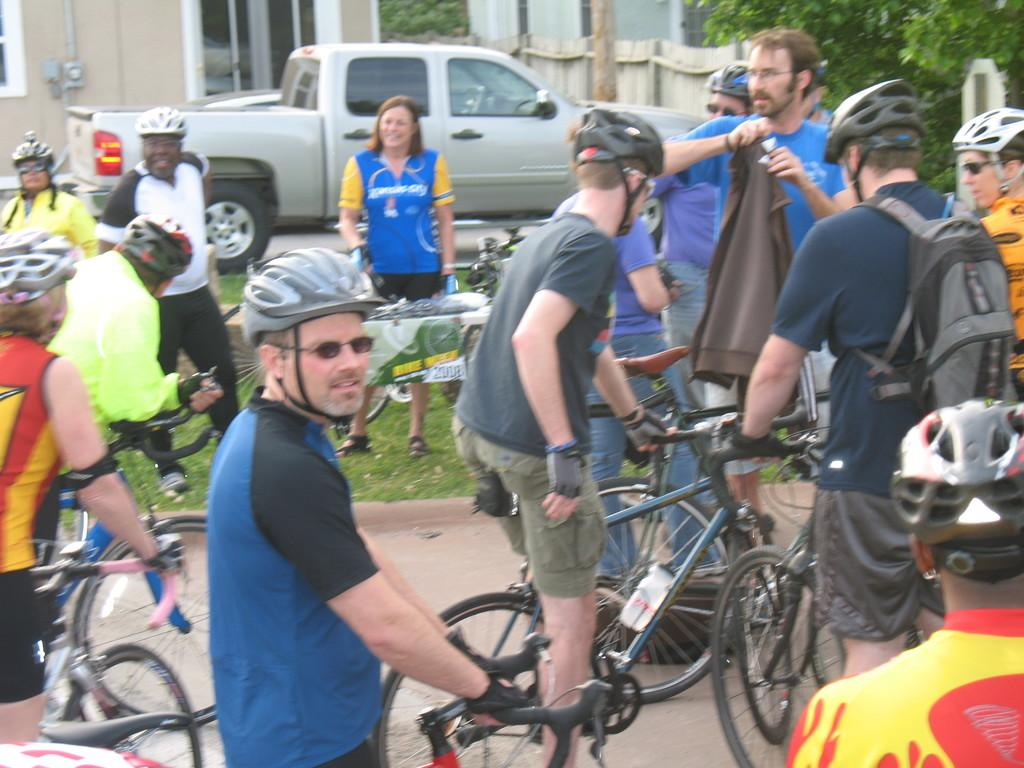What are the people in the image doing? The people in the image are sitting on a bicycle. What safety precaution are the people taking? The people are wearing helmets. What can be seen in the background of the image? There is a jeep and a house in the background of the image. What type of vegetation is on the right side of the image? There is a tree on the right side of the image. What does the boy's mouth look like in the image? There is no boy present in the image, so it is not possible to describe the appearance of his mouth. 